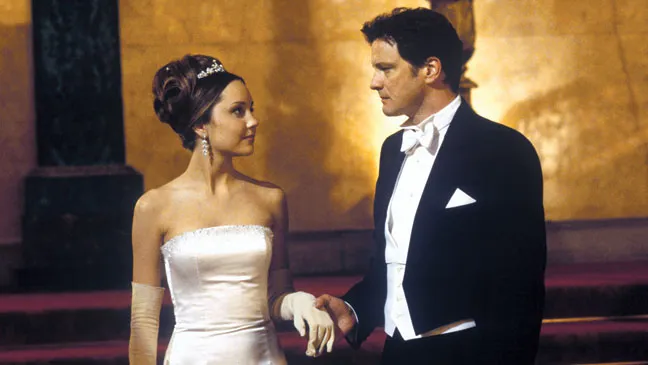Describe the emotions expressed by the characters in this scene. In this scene, Amanda Bynes’ character seems to be expressing warmth and admiration as she looks up at Colin Firth. Her smile and relaxed posture suggest she feels comfortable and perhaps grateful. On the other hand, Colin Firth’s character appears to be more serious. His expression and posture suggest he might be contemplating something important or feeling a sense of responsibility. The contrast in their expressions adds depth to this memorable moment in the film. Can you elaborate on what might be going through Colin Firth's mind? Colin Firth's serious expression could be due to a multitude of reasons. Given the formal setting, it's possible he's concerned about the societal expectations and the pressures of the event they are attending. He might be reflecting on the importance of his relationship with Amanda Bynes' character, weighing the consequences of their actions, or feeling the burden of a significant decision. His look of contemplation could also hint at emotional conflict, where despite the joyous occasion, he harbors unresolved feelings or memories from the past. 